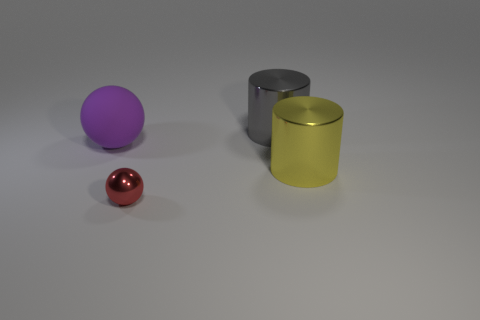Add 4 tiny cyan objects. How many objects exist? 8 Add 1 purple things. How many purple things exist? 2 Subtract 0 green cylinders. How many objects are left? 4 Subtract all metallic objects. Subtract all metal balls. How many objects are left? 0 Add 1 big balls. How many big balls are left? 2 